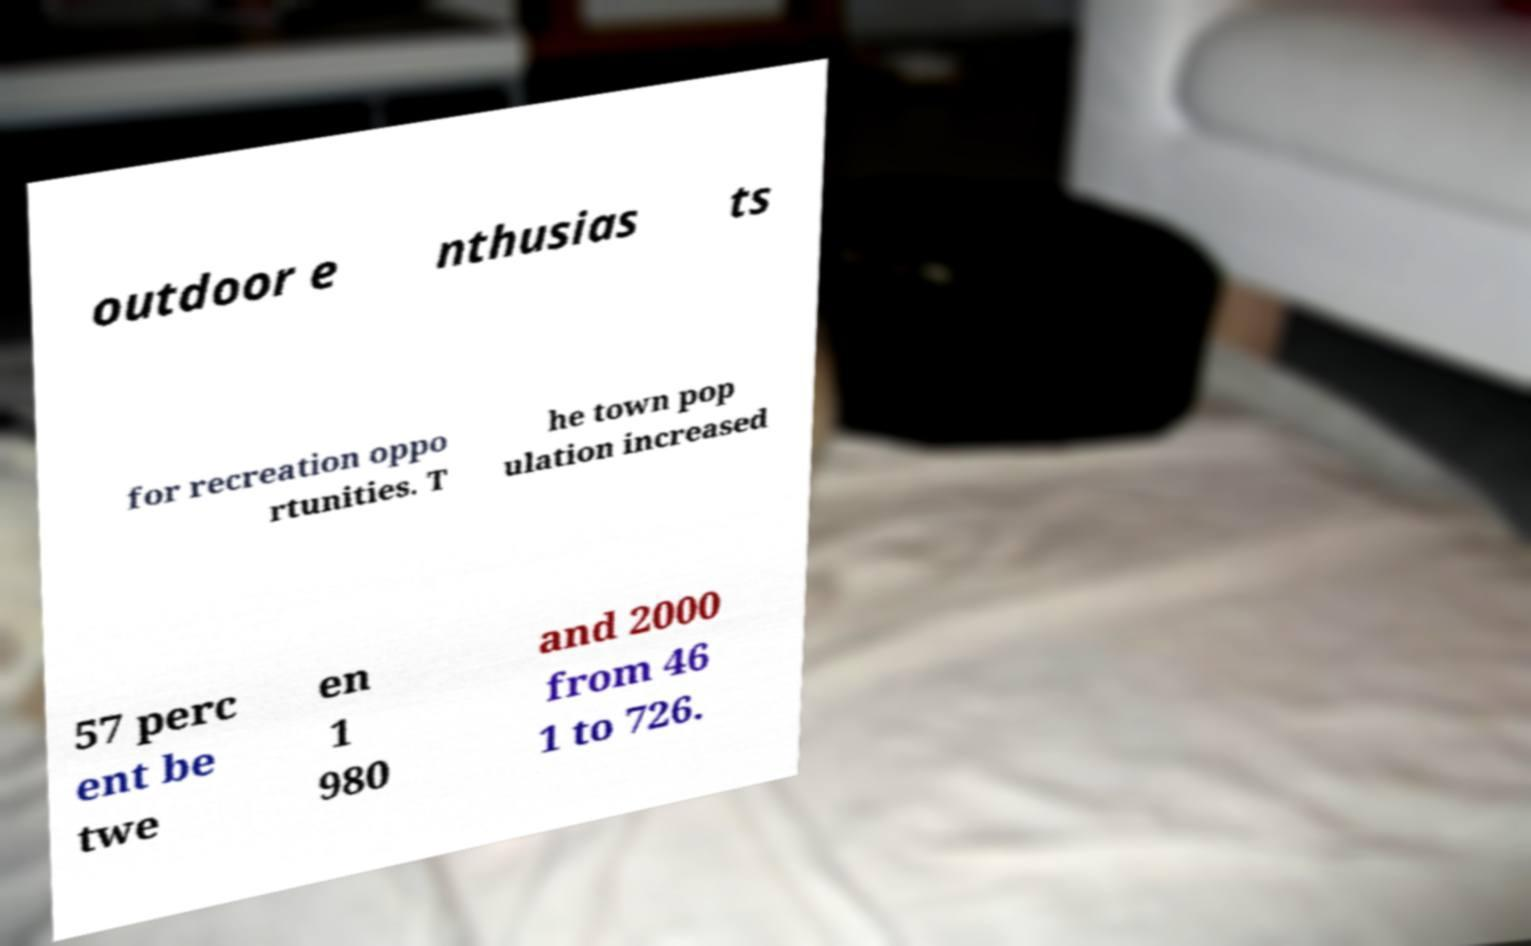For documentation purposes, I need the text within this image transcribed. Could you provide that? outdoor e nthusias ts for recreation oppo rtunities. T he town pop ulation increased 57 perc ent be twe en 1 980 and 2000 from 46 1 to 726. 